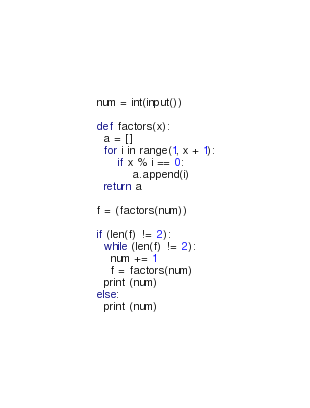Convert code to text. <code><loc_0><loc_0><loc_500><loc_500><_Python_>num = int(input())

def factors(x):
  a = []
  for i in range(1, x + 1):
      if x % i == 0:
          a.append(i)
  return a

f = (factors(num))

if (len(f) != 2): 
  while (len(f) != 2): 
    num += 1
    f = factors(num)
  print (num)
else: 
  print (num)</code> 